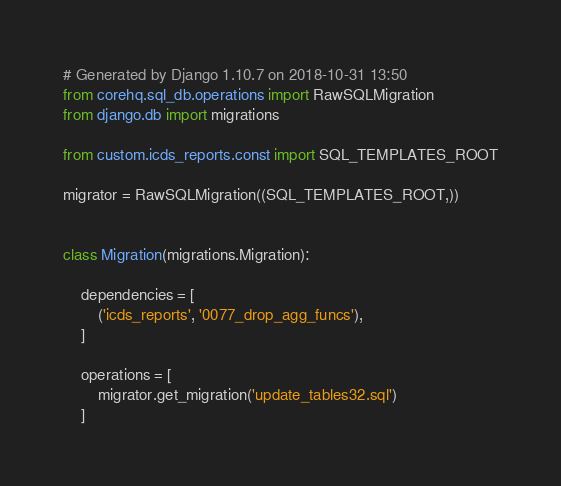Convert code to text. <code><loc_0><loc_0><loc_500><loc_500><_Python_># Generated by Django 1.10.7 on 2018-10-31 13:50
from corehq.sql_db.operations import RawSQLMigration
from django.db import migrations

from custom.icds_reports.const import SQL_TEMPLATES_ROOT

migrator = RawSQLMigration((SQL_TEMPLATES_ROOT,))


class Migration(migrations.Migration):

    dependencies = [
        ('icds_reports', '0077_drop_agg_funcs'),
    ]

    operations = [
        migrator.get_migration('update_tables32.sql')
    ]
</code> 